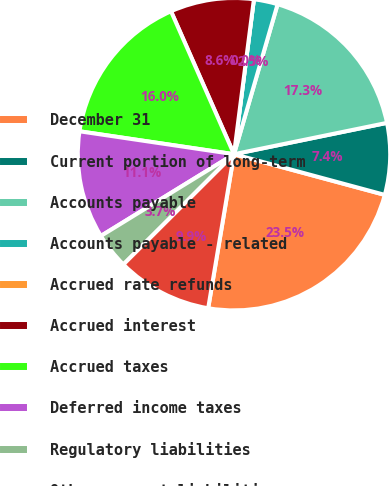Convert chart to OTSL. <chart><loc_0><loc_0><loc_500><loc_500><pie_chart><fcel>December 31<fcel>Current portion of long-term<fcel>Accounts payable<fcel>Accounts payable - related<fcel>Accrued rate refunds<fcel>Accrued interest<fcel>Accrued taxes<fcel>Deferred income taxes<fcel>Regulatory liabilities<fcel>Other current liabilities<nl><fcel>23.45%<fcel>7.41%<fcel>17.28%<fcel>2.47%<fcel>0.0%<fcel>8.64%<fcel>16.05%<fcel>11.11%<fcel>3.71%<fcel>9.88%<nl></chart> 